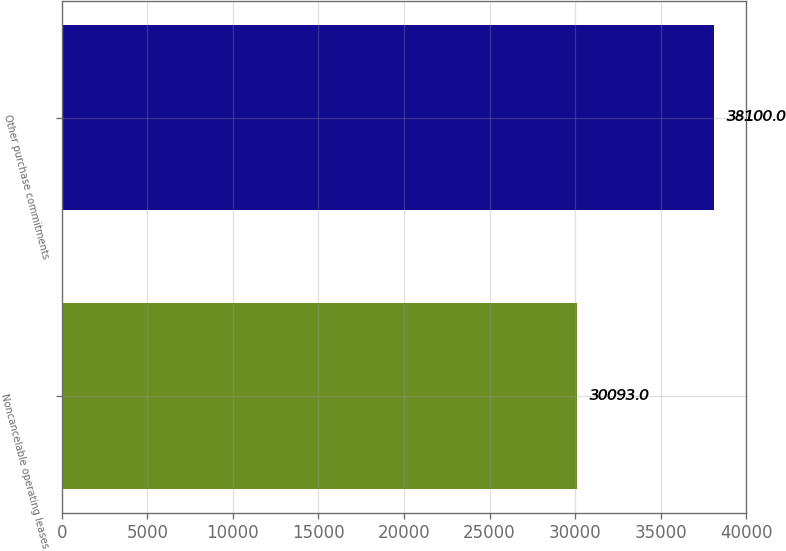Convert chart. <chart><loc_0><loc_0><loc_500><loc_500><bar_chart><fcel>Noncancelable operating leases<fcel>Other purchase commitments<nl><fcel>30093<fcel>38100<nl></chart> 